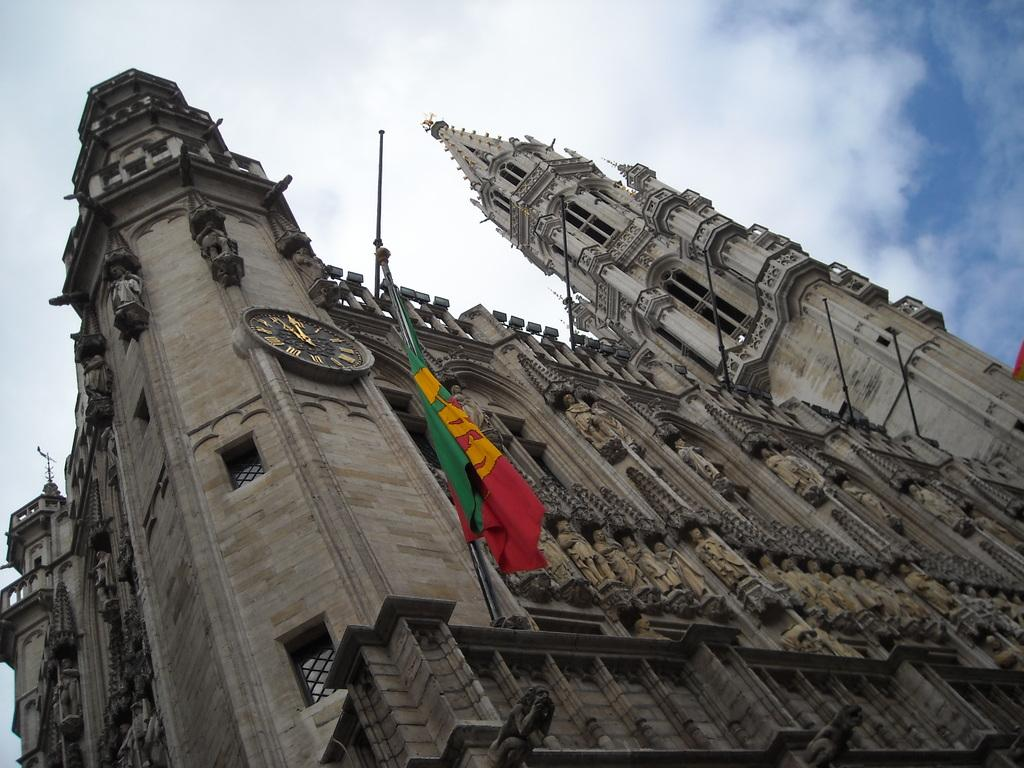What structure is depicted in the image? There is a building in the image. What can be seen on the building? There is a wall clock and a flag on the building. What is visible in the background of the image? The sky is visible in the background of the image. What type of mouth can be seen on the building in the image? There is no mouth present on the building in the image. How many people are gathered in a group in front of the building in the image? There is no group of people present in front of the building in the image. 